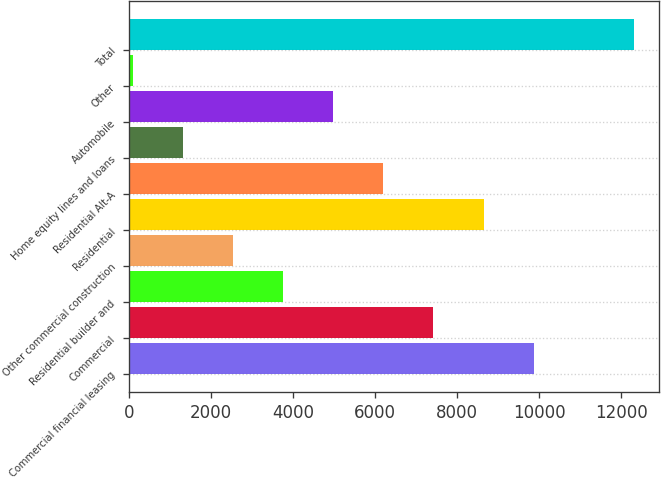Convert chart to OTSL. <chart><loc_0><loc_0><loc_500><loc_500><bar_chart><fcel>Commercial financial leasing<fcel>Commercial<fcel>Residential builder and<fcel>Other commercial construction<fcel>Residential<fcel>Residential Alt-A<fcel>Home equity lines and loans<fcel>Automobile<fcel>Other<fcel>Total<nl><fcel>9868.2<fcel>7423.4<fcel>3756.2<fcel>2533.8<fcel>8645.8<fcel>6201<fcel>1311.4<fcel>4978.6<fcel>89<fcel>12313<nl></chart> 